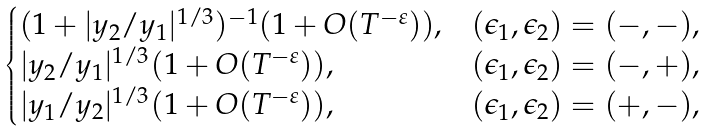Convert formula to latex. <formula><loc_0><loc_0><loc_500><loc_500>\begin{cases} ( 1 + | y _ { 2 } / y _ { 1 } | ^ { 1 / 3 } ) ^ { - 1 } ( 1 + O ( T ^ { - \varepsilon } ) ) , & ( \epsilon _ { 1 } , \epsilon _ { 2 } ) = ( - , - ) , \\ | y _ { 2 } / y _ { 1 } | ^ { 1 / 3 } ( 1 + O ( T ^ { - \varepsilon } ) ) , & ( \epsilon _ { 1 } , \epsilon _ { 2 } ) = ( - , + ) , \\ | y _ { 1 } / y _ { 2 } | ^ { 1 / 3 } ( 1 + O ( T ^ { - \varepsilon } ) ) , & ( \epsilon _ { 1 } , \epsilon _ { 2 } ) = ( + , - ) , \end{cases}</formula> 